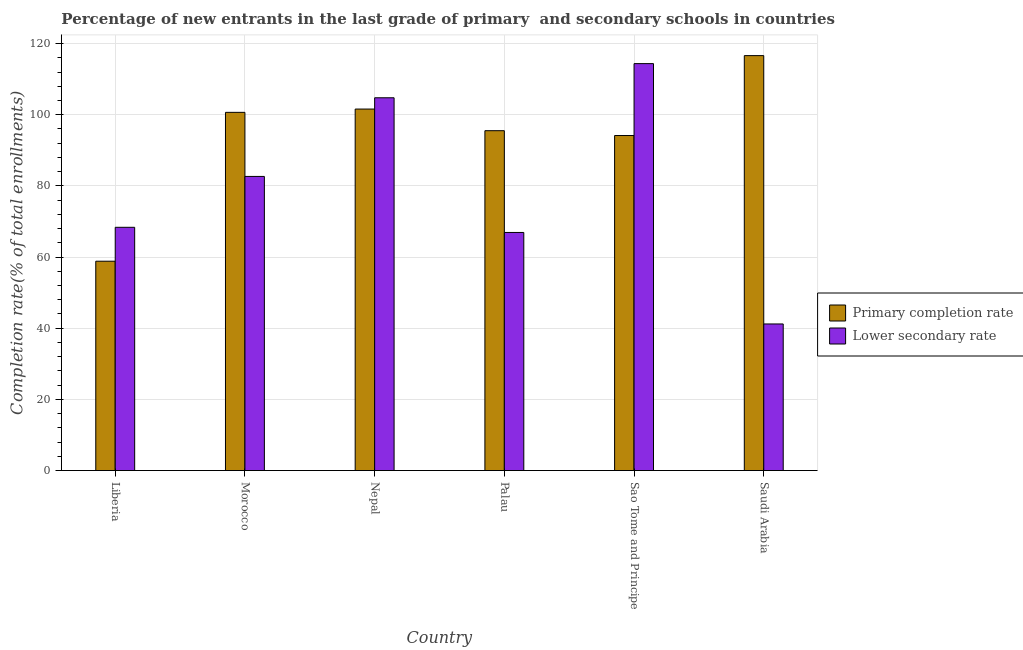How many groups of bars are there?
Offer a very short reply. 6. Are the number of bars per tick equal to the number of legend labels?
Keep it short and to the point. Yes. Are the number of bars on each tick of the X-axis equal?
Your answer should be compact. Yes. How many bars are there on the 5th tick from the left?
Give a very brief answer. 2. What is the label of the 5th group of bars from the left?
Make the answer very short. Sao Tome and Principe. What is the completion rate in secondary schools in Palau?
Ensure brevity in your answer.  66.91. Across all countries, what is the maximum completion rate in secondary schools?
Offer a very short reply. 114.36. Across all countries, what is the minimum completion rate in secondary schools?
Make the answer very short. 41.2. In which country was the completion rate in secondary schools maximum?
Ensure brevity in your answer.  Sao Tome and Principe. In which country was the completion rate in primary schools minimum?
Keep it short and to the point. Liberia. What is the total completion rate in secondary schools in the graph?
Your response must be concise. 478.25. What is the difference between the completion rate in secondary schools in Liberia and that in Nepal?
Give a very brief answer. -36.4. What is the difference between the completion rate in primary schools in Nepal and the completion rate in secondary schools in Palau?
Offer a very short reply. 34.68. What is the average completion rate in primary schools per country?
Keep it short and to the point. 94.56. What is the difference between the completion rate in primary schools and completion rate in secondary schools in Sao Tome and Principe?
Keep it short and to the point. -20.21. In how many countries, is the completion rate in primary schools greater than 60 %?
Keep it short and to the point. 5. What is the ratio of the completion rate in secondary schools in Nepal to that in Palau?
Ensure brevity in your answer.  1.57. Is the completion rate in secondary schools in Palau less than that in Sao Tome and Principe?
Your answer should be compact. Yes. Is the difference between the completion rate in primary schools in Morocco and Nepal greater than the difference between the completion rate in secondary schools in Morocco and Nepal?
Keep it short and to the point. Yes. What is the difference between the highest and the second highest completion rate in secondary schools?
Keep it short and to the point. 9.59. What is the difference between the highest and the lowest completion rate in primary schools?
Offer a terse response. 57.77. In how many countries, is the completion rate in primary schools greater than the average completion rate in primary schools taken over all countries?
Your response must be concise. 4. What does the 2nd bar from the left in Morocco represents?
Offer a terse response. Lower secondary rate. What does the 2nd bar from the right in Liberia represents?
Ensure brevity in your answer.  Primary completion rate. How many bars are there?
Provide a short and direct response. 12. Are all the bars in the graph horizontal?
Ensure brevity in your answer.  No. How many countries are there in the graph?
Provide a succinct answer. 6. What is the difference between two consecutive major ticks on the Y-axis?
Your response must be concise. 20. How many legend labels are there?
Keep it short and to the point. 2. How are the legend labels stacked?
Offer a very short reply. Vertical. What is the title of the graph?
Your response must be concise. Percentage of new entrants in the last grade of primary  and secondary schools in countries. What is the label or title of the X-axis?
Offer a terse response. Country. What is the label or title of the Y-axis?
Your response must be concise. Completion rate(% of total enrollments). What is the Completion rate(% of total enrollments) in Primary completion rate in Liberia?
Make the answer very short. 58.83. What is the Completion rate(% of total enrollments) in Lower secondary rate in Liberia?
Give a very brief answer. 68.36. What is the Completion rate(% of total enrollments) of Primary completion rate in Morocco?
Offer a very short reply. 100.66. What is the Completion rate(% of total enrollments) of Lower secondary rate in Morocco?
Provide a succinct answer. 82.66. What is the Completion rate(% of total enrollments) in Primary completion rate in Nepal?
Offer a very short reply. 101.59. What is the Completion rate(% of total enrollments) in Lower secondary rate in Nepal?
Provide a succinct answer. 104.76. What is the Completion rate(% of total enrollments) in Primary completion rate in Palau?
Ensure brevity in your answer.  95.51. What is the Completion rate(% of total enrollments) in Lower secondary rate in Palau?
Your answer should be very brief. 66.91. What is the Completion rate(% of total enrollments) in Primary completion rate in Sao Tome and Principe?
Provide a succinct answer. 94.15. What is the Completion rate(% of total enrollments) in Lower secondary rate in Sao Tome and Principe?
Offer a very short reply. 114.36. What is the Completion rate(% of total enrollments) of Primary completion rate in Saudi Arabia?
Ensure brevity in your answer.  116.6. What is the Completion rate(% of total enrollments) of Lower secondary rate in Saudi Arabia?
Offer a terse response. 41.2. Across all countries, what is the maximum Completion rate(% of total enrollments) of Primary completion rate?
Give a very brief answer. 116.6. Across all countries, what is the maximum Completion rate(% of total enrollments) in Lower secondary rate?
Your answer should be compact. 114.36. Across all countries, what is the minimum Completion rate(% of total enrollments) of Primary completion rate?
Keep it short and to the point. 58.83. Across all countries, what is the minimum Completion rate(% of total enrollments) in Lower secondary rate?
Make the answer very short. 41.2. What is the total Completion rate(% of total enrollments) of Primary completion rate in the graph?
Provide a succinct answer. 567.36. What is the total Completion rate(% of total enrollments) of Lower secondary rate in the graph?
Your answer should be compact. 478.25. What is the difference between the Completion rate(% of total enrollments) in Primary completion rate in Liberia and that in Morocco?
Offer a very short reply. -41.83. What is the difference between the Completion rate(% of total enrollments) of Lower secondary rate in Liberia and that in Morocco?
Ensure brevity in your answer.  -14.3. What is the difference between the Completion rate(% of total enrollments) of Primary completion rate in Liberia and that in Nepal?
Your response must be concise. -42.76. What is the difference between the Completion rate(% of total enrollments) of Lower secondary rate in Liberia and that in Nepal?
Your response must be concise. -36.4. What is the difference between the Completion rate(% of total enrollments) of Primary completion rate in Liberia and that in Palau?
Provide a succinct answer. -36.68. What is the difference between the Completion rate(% of total enrollments) in Lower secondary rate in Liberia and that in Palau?
Provide a succinct answer. 1.45. What is the difference between the Completion rate(% of total enrollments) of Primary completion rate in Liberia and that in Sao Tome and Principe?
Offer a terse response. -35.32. What is the difference between the Completion rate(% of total enrollments) of Lower secondary rate in Liberia and that in Sao Tome and Principe?
Offer a terse response. -46. What is the difference between the Completion rate(% of total enrollments) of Primary completion rate in Liberia and that in Saudi Arabia?
Your response must be concise. -57.77. What is the difference between the Completion rate(% of total enrollments) of Lower secondary rate in Liberia and that in Saudi Arabia?
Give a very brief answer. 27.16. What is the difference between the Completion rate(% of total enrollments) in Primary completion rate in Morocco and that in Nepal?
Ensure brevity in your answer.  -0.93. What is the difference between the Completion rate(% of total enrollments) of Lower secondary rate in Morocco and that in Nepal?
Offer a very short reply. -22.1. What is the difference between the Completion rate(% of total enrollments) of Primary completion rate in Morocco and that in Palau?
Ensure brevity in your answer.  5.15. What is the difference between the Completion rate(% of total enrollments) in Lower secondary rate in Morocco and that in Palau?
Provide a short and direct response. 15.75. What is the difference between the Completion rate(% of total enrollments) in Primary completion rate in Morocco and that in Sao Tome and Principe?
Make the answer very short. 6.51. What is the difference between the Completion rate(% of total enrollments) in Lower secondary rate in Morocco and that in Sao Tome and Principe?
Ensure brevity in your answer.  -31.7. What is the difference between the Completion rate(% of total enrollments) of Primary completion rate in Morocco and that in Saudi Arabia?
Provide a short and direct response. -15.94. What is the difference between the Completion rate(% of total enrollments) of Lower secondary rate in Morocco and that in Saudi Arabia?
Keep it short and to the point. 41.46. What is the difference between the Completion rate(% of total enrollments) of Primary completion rate in Nepal and that in Palau?
Offer a very short reply. 6.08. What is the difference between the Completion rate(% of total enrollments) of Lower secondary rate in Nepal and that in Palau?
Keep it short and to the point. 37.85. What is the difference between the Completion rate(% of total enrollments) of Primary completion rate in Nepal and that in Sao Tome and Principe?
Keep it short and to the point. 7.44. What is the difference between the Completion rate(% of total enrollments) in Lower secondary rate in Nepal and that in Sao Tome and Principe?
Offer a very short reply. -9.59. What is the difference between the Completion rate(% of total enrollments) of Primary completion rate in Nepal and that in Saudi Arabia?
Your answer should be compact. -15.01. What is the difference between the Completion rate(% of total enrollments) in Lower secondary rate in Nepal and that in Saudi Arabia?
Offer a terse response. 63.56. What is the difference between the Completion rate(% of total enrollments) in Primary completion rate in Palau and that in Sao Tome and Principe?
Ensure brevity in your answer.  1.36. What is the difference between the Completion rate(% of total enrollments) of Lower secondary rate in Palau and that in Sao Tome and Principe?
Provide a short and direct response. -47.45. What is the difference between the Completion rate(% of total enrollments) of Primary completion rate in Palau and that in Saudi Arabia?
Your answer should be very brief. -21.09. What is the difference between the Completion rate(% of total enrollments) of Lower secondary rate in Palau and that in Saudi Arabia?
Provide a short and direct response. 25.71. What is the difference between the Completion rate(% of total enrollments) in Primary completion rate in Sao Tome and Principe and that in Saudi Arabia?
Your answer should be compact. -22.45. What is the difference between the Completion rate(% of total enrollments) in Lower secondary rate in Sao Tome and Principe and that in Saudi Arabia?
Offer a very short reply. 73.16. What is the difference between the Completion rate(% of total enrollments) of Primary completion rate in Liberia and the Completion rate(% of total enrollments) of Lower secondary rate in Morocco?
Your response must be concise. -23.83. What is the difference between the Completion rate(% of total enrollments) of Primary completion rate in Liberia and the Completion rate(% of total enrollments) of Lower secondary rate in Nepal?
Provide a succinct answer. -45.93. What is the difference between the Completion rate(% of total enrollments) of Primary completion rate in Liberia and the Completion rate(% of total enrollments) of Lower secondary rate in Palau?
Keep it short and to the point. -8.08. What is the difference between the Completion rate(% of total enrollments) in Primary completion rate in Liberia and the Completion rate(% of total enrollments) in Lower secondary rate in Sao Tome and Principe?
Ensure brevity in your answer.  -55.52. What is the difference between the Completion rate(% of total enrollments) in Primary completion rate in Liberia and the Completion rate(% of total enrollments) in Lower secondary rate in Saudi Arabia?
Keep it short and to the point. 17.63. What is the difference between the Completion rate(% of total enrollments) of Primary completion rate in Morocco and the Completion rate(% of total enrollments) of Lower secondary rate in Nepal?
Your response must be concise. -4.1. What is the difference between the Completion rate(% of total enrollments) of Primary completion rate in Morocco and the Completion rate(% of total enrollments) of Lower secondary rate in Palau?
Ensure brevity in your answer.  33.75. What is the difference between the Completion rate(% of total enrollments) of Primary completion rate in Morocco and the Completion rate(% of total enrollments) of Lower secondary rate in Sao Tome and Principe?
Your answer should be very brief. -13.69. What is the difference between the Completion rate(% of total enrollments) in Primary completion rate in Morocco and the Completion rate(% of total enrollments) in Lower secondary rate in Saudi Arabia?
Offer a very short reply. 59.46. What is the difference between the Completion rate(% of total enrollments) of Primary completion rate in Nepal and the Completion rate(% of total enrollments) of Lower secondary rate in Palau?
Ensure brevity in your answer.  34.68. What is the difference between the Completion rate(% of total enrollments) in Primary completion rate in Nepal and the Completion rate(% of total enrollments) in Lower secondary rate in Sao Tome and Principe?
Your answer should be compact. -12.76. What is the difference between the Completion rate(% of total enrollments) of Primary completion rate in Nepal and the Completion rate(% of total enrollments) of Lower secondary rate in Saudi Arabia?
Give a very brief answer. 60.39. What is the difference between the Completion rate(% of total enrollments) in Primary completion rate in Palau and the Completion rate(% of total enrollments) in Lower secondary rate in Sao Tome and Principe?
Offer a terse response. -18.85. What is the difference between the Completion rate(% of total enrollments) in Primary completion rate in Palau and the Completion rate(% of total enrollments) in Lower secondary rate in Saudi Arabia?
Provide a succinct answer. 54.31. What is the difference between the Completion rate(% of total enrollments) in Primary completion rate in Sao Tome and Principe and the Completion rate(% of total enrollments) in Lower secondary rate in Saudi Arabia?
Keep it short and to the point. 52.95. What is the average Completion rate(% of total enrollments) in Primary completion rate per country?
Provide a short and direct response. 94.56. What is the average Completion rate(% of total enrollments) in Lower secondary rate per country?
Give a very brief answer. 79.71. What is the difference between the Completion rate(% of total enrollments) in Primary completion rate and Completion rate(% of total enrollments) in Lower secondary rate in Liberia?
Provide a short and direct response. -9.53. What is the difference between the Completion rate(% of total enrollments) in Primary completion rate and Completion rate(% of total enrollments) in Lower secondary rate in Morocco?
Provide a succinct answer. 18.01. What is the difference between the Completion rate(% of total enrollments) of Primary completion rate and Completion rate(% of total enrollments) of Lower secondary rate in Nepal?
Your response must be concise. -3.17. What is the difference between the Completion rate(% of total enrollments) of Primary completion rate and Completion rate(% of total enrollments) of Lower secondary rate in Palau?
Your response must be concise. 28.6. What is the difference between the Completion rate(% of total enrollments) of Primary completion rate and Completion rate(% of total enrollments) of Lower secondary rate in Sao Tome and Principe?
Provide a succinct answer. -20.21. What is the difference between the Completion rate(% of total enrollments) of Primary completion rate and Completion rate(% of total enrollments) of Lower secondary rate in Saudi Arabia?
Your response must be concise. 75.4. What is the ratio of the Completion rate(% of total enrollments) of Primary completion rate in Liberia to that in Morocco?
Offer a terse response. 0.58. What is the ratio of the Completion rate(% of total enrollments) of Lower secondary rate in Liberia to that in Morocco?
Keep it short and to the point. 0.83. What is the ratio of the Completion rate(% of total enrollments) in Primary completion rate in Liberia to that in Nepal?
Offer a very short reply. 0.58. What is the ratio of the Completion rate(% of total enrollments) in Lower secondary rate in Liberia to that in Nepal?
Offer a very short reply. 0.65. What is the ratio of the Completion rate(% of total enrollments) of Primary completion rate in Liberia to that in Palau?
Your answer should be compact. 0.62. What is the ratio of the Completion rate(% of total enrollments) in Lower secondary rate in Liberia to that in Palau?
Your answer should be very brief. 1.02. What is the ratio of the Completion rate(% of total enrollments) in Primary completion rate in Liberia to that in Sao Tome and Principe?
Your response must be concise. 0.62. What is the ratio of the Completion rate(% of total enrollments) of Lower secondary rate in Liberia to that in Sao Tome and Principe?
Your response must be concise. 0.6. What is the ratio of the Completion rate(% of total enrollments) of Primary completion rate in Liberia to that in Saudi Arabia?
Your response must be concise. 0.5. What is the ratio of the Completion rate(% of total enrollments) in Lower secondary rate in Liberia to that in Saudi Arabia?
Offer a very short reply. 1.66. What is the ratio of the Completion rate(% of total enrollments) in Primary completion rate in Morocco to that in Nepal?
Keep it short and to the point. 0.99. What is the ratio of the Completion rate(% of total enrollments) in Lower secondary rate in Morocco to that in Nepal?
Ensure brevity in your answer.  0.79. What is the ratio of the Completion rate(% of total enrollments) of Primary completion rate in Morocco to that in Palau?
Your response must be concise. 1.05. What is the ratio of the Completion rate(% of total enrollments) in Lower secondary rate in Morocco to that in Palau?
Your answer should be very brief. 1.24. What is the ratio of the Completion rate(% of total enrollments) in Primary completion rate in Morocco to that in Sao Tome and Principe?
Offer a very short reply. 1.07. What is the ratio of the Completion rate(% of total enrollments) of Lower secondary rate in Morocco to that in Sao Tome and Principe?
Make the answer very short. 0.72. What is the ratio of the Completion rate(% of total enrollments) of Primary completion rate in Morocco to that in Saudi Arabia?
Provide a succinct answer. 0.86. What is the ratio of the Completion rate(% of total enrollments) of Lower secondary rate in Morocco to that in Saudi Arabia?
Offer a terse response. 2.01. What is the ratio of the Completion rate(% of total enrollments) in Primary completion rate in Nepal to that in Palau?
Give a very brief answer. 1.06. What is the ratio of the Completion rate(% of total enrollments) in Lower secondary rate in Nepal to that in Palau?
Provide a short and direct response. 1.57. What is the ratio of the Completion rate(% of total enrollments) of Primary completion rate in Nepal to that in Sao Tome and Principe?
Make the answer very short. 1.08. What is the ratio of the Completion rate(% of total enrollments) of Lower secondary rate in Nepal to that in Sao Tome and Principe?
Your answer should be compact. 0.92. What is the ratio of the Completion rate(% of total enrollments) in Primary completion rate in Nepal to that in Saudi Arabia?
Your response must be concise. 0.87. What is the ratio of the Completion rate(% of total enrollments) in Lower secondary rate in Nepal to that in Saudi Arabia?
Your answer should be very brief. 2.54. What is the ratio of the Completion rate(% of total enrollments) of Primary completion rate in Palau to that in Sao Tome and Principe?
Make the answer very short. 1.01. What is the ratio of the Completion rate(% of total enrollments) of Lower secondary rate in Palau to that in Sao Tome and Principe?
Offer a terse response. 0.59. What is the ratio of the Completion rate(% of total enrollments) in Primary completion rate in Palau to that in Saudi Arabia?
Provide a short and direct response. 0.82. What is the ratio of the Completion rate(% of total enrollments) in Lower secondary rate in Palau to that in Saudi Arabia?
Offer a terse response. 1.62. What is the ratio of the Completion rate(% of total enrollments) of Primary completion rate in Sao Tome and Principe to that in Saudi Arabia?
Offer a very short reply. 0.81. What is the ratio of the Completion rate(% of total enrollments) of Lower secondary rate in Sao Tome and Principe to that in Saudi Arabia?
Keep it short and to the point. 2.78. What is the difference between the highest and the second highest Completion rate(% of total enrollments) in Primary completion rate?
Your response must be concise. 15.01. What is the difference between the highest and the second highest Completion rate(% of total enrollments) in Lower secondary rate?
Provide a short and direct response. 9.59. What is the difference between the highest and the lowest Completion rate(% of total enrollments) in Primary completion rate?
Offer a very short reply. 57.77. What is the difference between the highest and the lowest Completion rate(% of total enrollments) of Lower secondary rate?
Offer a very short reply. 73.16. 